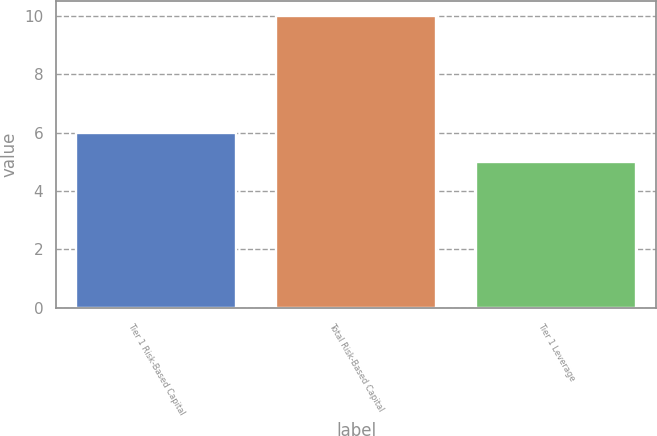Convert chart to OTSL. <chart><loc_0><loc_0><loc_500><loc_500><bar_chart><fcel>Tier 1 Risk-Based Capital<fcel>Total Risk-Based Capital<fcel>Tier 1 Leverage<nl><fcel>6<fcel>10<fcel>5<nl></chart> 